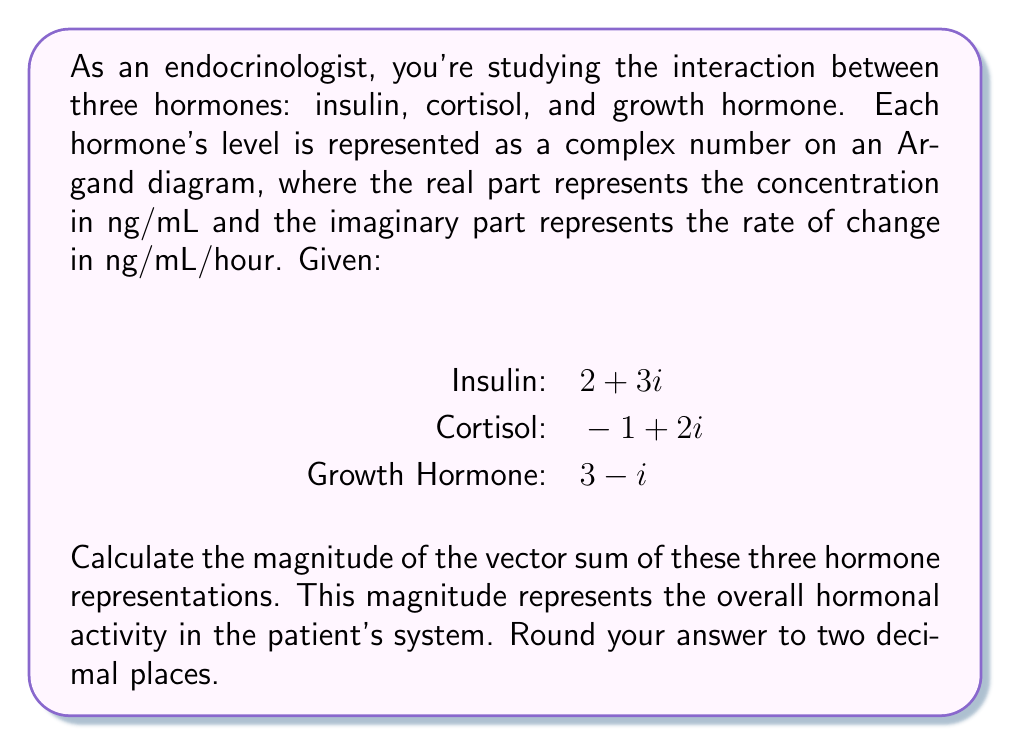What is the answer to this math problem? To solve this problem, we'll follow these steps:

1) First, we need to find the vector sum of the three complex numbers representing the hormones:

   $$(2 + 3i) + (-1 + 2i) + (3 - i) = (2 - 1 + 3) + (3 + 2 - 1)i = 4 + 4i$$

2) Now we have a single complex number $4 + 4i$ representing the overall hormonal activity.

3) To find the magnitude of this complex number, we use the formula:

   $$|a + bi| = \sqrt{a^2 + b^2}$$

   Where $a$ is the real part and $b$ is the imaginary part.

4) Substituting our values:

   $$|4 + 4i| = \sqrt{4^2 + 4^2} = \sqrt{16 + 16} = \sqrt{32}$$

5) Simplify:
   
   $$\sqrt{32} = 4\sqrt{2} \approx 5.66$$

6) Rounding to two decimal places gives us 5.66.

This magnitude represents the overall hormonal activity in the patient's system, taking into account both the concentration and rate of change of each hormone.
Answer: 5.66 